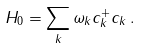<formula> <loc_0><loc_0><loc_500><loc_500>H _ { 0 } = \sum _ { k } \omega _ { k } c _ { k } ^ { + } c _ { k } \, .</formula> 